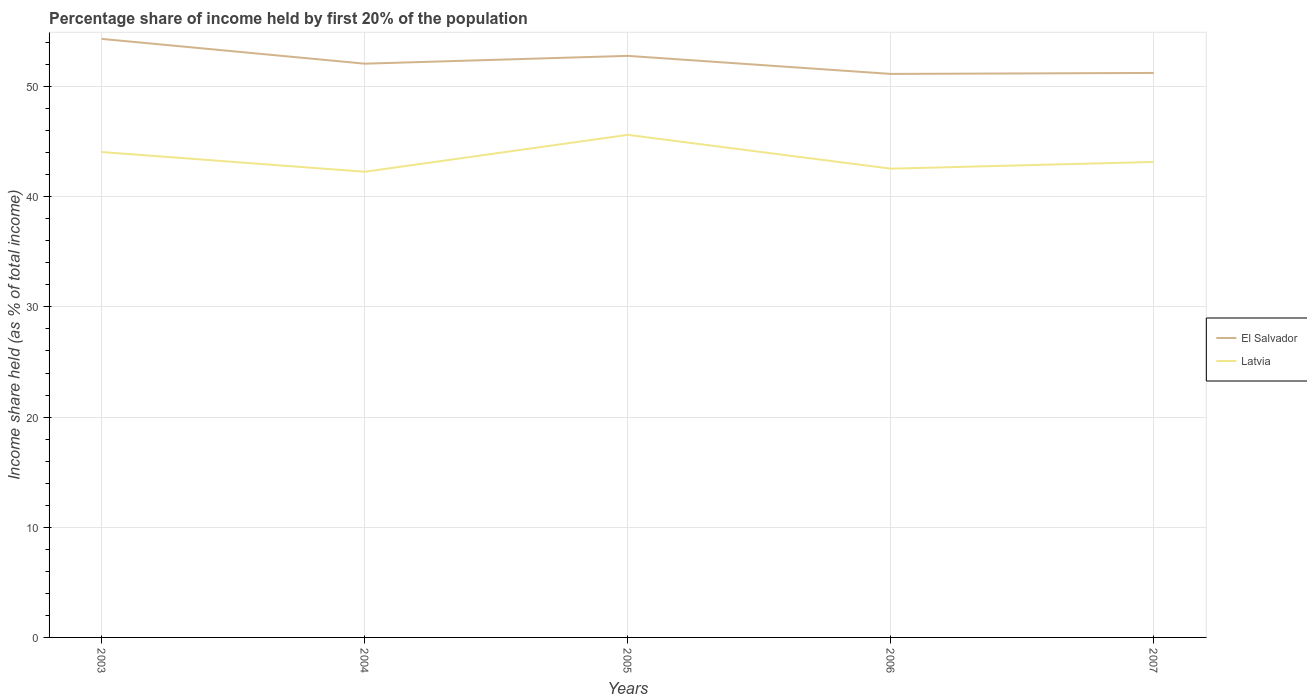How many different coloured lines are there?
Make the answer very short. 2. Does the line corresponding to Latvia intersect with the line corresponding to El Salvador?
Make the answer very short. No. Is the number of lines equal to the number of legend labels?
Provide a succinct answer. Yes. Across all years, what is the maximum share of income held by first 20% of the population in El Salvador?
Offer a very short reply. 51.15. What is the total share of income held by first 20% of the population in Latvia in the graph?
Your answer should be very brief. -0.28. What is the difference between the highest and the second highest share of income held by first 20% of the population in El Salvador?
Provide a short and direct response. 3.18. How many years are there in the graph?
Keep it short and to the point. 5. Does the graph contain any zero values?
Ensure brevity in your answer.  No. Does the graph contain grids?
Offer a very short reply. Yes. Where does the legend appear in the graph?
Keep it short and to the point. Center right. How are the legend labels stacked?
Offer a terse response. Vertical. What is the title of the graph?
Provide a short and direct response. Percentage share of income held by first 20% of the population. What is the label or title of the Y-axis?
Your response must be concise. Income share held (as % of total income). What is the Income share held (as % of total income) of El Salvador in 2003?
Make the answer very short. 54.33. What is the Income share held (as % of total income) of Latvia in 2003?
Give a very brief answer. 44.06. What is the Income share held (as % of total income) of El Salvador in 2004?
Your answer should be very brief. 52.08. What is the Income share held (as % of total income) of Latvia in 2004?
Provide a succinct answer. 42.27. What is the Income share held (as % of total income) of El Salvador in 2005?
Provide a succinct answer. 52.79. What is the Income share held (as % of total income) of Latvia in 2005?
Offer a terse response. 45.62. What is the Income share held (as % of total income) in El Salvador in 2006?
Offer a terse response. 51.15. What is the Income share held (as % of total income) of Latvia in 2006?
Provide a succinct answer. 42.55. What is the Income share held (as % of total income) of El Salvador in 2007?
Make the answer very short. 51.24. What is the Income share held (as % of total income) in Latvia in 2007?
Provide a short and direct response. 43.16. Across all years, what is the maximum Income share held (as % of total income) in El Salvador?
Provide a succinct answer. 54.33. Across all years, what is the maximum Income share held (as % of total income) of Latvia?
Your response must be concise. 45.62. Across all years, what is the minimum Income share held (as % of total income) of El Salvador?
Offer a terse response. 51.15. Across all years, what is the minimum Income share held (as % of total income) of Latvia?
Ensure brevity in your answer.  42.27. What is the total Income share held (as % of total income) of El Salvador in the graph?
Make the answer very short. 261.59. What is the total Income share held (as % of total income) in Latvia in the graph?
Your answer should be compact. 217.66. What is the difference between the Income share held (as % of total income) of El Salvador in 2003 and that in 2004?
Ensure brevity in your answer.  2.25. What is the difference between the Income share held (as % of total income) of Latvia in 2003 and that in 2004?
Give a very brief answer. 1.79. What is the difference between the Income share held (as % of total income) of El Salvador in 2003 and that in 2005?
Your response must be concise. 1.54. What is the difference between the Income share held (as % of total income) of Latvia in 2003 and that in 2005?
Provide a short and direct response. -1.56. What is the difference between the Income share held (as % of total income) in El Salvador in 2003 and that in 2006?
Your response must be concise. 3.18. What is the difference between the Income share held (as % of total income) of Latvia in 2003 and that in 2006?
Your answer should be compact. 1.51. What is the difference between the Income share held (as % of total income) of El Salvador in 2003 and that in 2007?
Ensure brevity in your answer.  3.09. What is the difference between the Income share held (as % of total income) in Latvia in 2003 and that in 2007?
Your answer should be very brief. 0.9. What is the difference between the Income share held (as % of total income) in El Salvador in 2004 and that in 2005?
Give a very brief answer. -0.71. What is the difference between the Income share held (as % of total income) of Latvia in 2004 and that in 2005?
Keep it short and to the point. -3.35. What is the difference between the Income share held (as % of total income) of El Salvador in 2004 and that in 2006?
Make the answer very short. 0.93. What is the difference between the Income share held (as % of total income) of Latvia in 2004 and that in 2006?
Offer a terse response. -0.28. What is the difference between the Income share held (as % of total income) in El Salvador in 2004 and that in 2007?
Your answer should be compact. 0.84. What is the difference between the Income share held (as % of total income) of Latvia in 2004 and that in 2007?
Your response must be concise. -0.89. What is the difference between the Income share held (as % of total income) of El Salvador in 2005 and that in 2006?
Offer a terse response. 1.64. What is the difference between the Income share held (as % of total income) of Latvia in 2005 and that in 2006?
Offer a very short reply. 3.07. What is the difference between the Income share held (as % of total income) in El Salvador in 2005 and that in 2007?
Offer a terse response. 1.55. What is the difference between the Income share held (as % of total income) of Latvia in 2005 and that in 2007?
Ensure brevity in your answer.  2.46. What is the difference between the Income share held (as % of total income) of El Salvador in 2006 and that in 2007?
Offer a very short reply. -0.09. What is the difference between the Income share held (as % of total income) in Latvia in 2006 and that in 2007?
Your answer should be compact. -0.61. What is the difference between the Income share held (as % of total income) in El Salvador in 2003 and the Income share held (as % of total income) in Latvia in 2004?
Make the answer very short. 12.06. What is the difference between the Income share held (as % of total income) of El Salvador in 2003 and the Income share held (as % of total income) of Latvia in 2005?
Your answer should be very brief. 8.71. What is the difference between the Income share held (as % of total income) in El Salvador in 2003 and the Income share held (as % of total income) in Latvia in 2006?
Your answer should be compact. 11.78. What is the difference between the Income share held (as % of total income) of El Salvador in 2003 and the Income share held (as % of total income) of Latvia in 2007?
Ensure brevity in your answer.  11.17. What is the difference between the Income share held (as % of total income) of El Salvador in 2004 and the Income share held (as % of total income) of Latvia in 2005?
Offer a very short reply. 6.46. What is the difference between the Income share held (as % of total income) of El Salvador in 2004 and the Income share held (as % of total income) of Latvia in 2006?
Give a very brief answer. 9.53. What is the difference between the Income share held (as % of total income) in El Salvador in 2004 and the Income share held (as % of total income) in Latvia in 2007?
Your response must be concise. 8.92. What is the difference between the Income share held (as % of total income) in El Salvador in 2005 and the Income share held (as % of total income) in Latvia in 2006?
Provide a short and direct response. 10.24. What is the difference between the Income share held (as % of total income) in El Salvador in 2005 and the Income share held (as % of total income) in Latvia in 2007?
Offer a terse response. 9.63. What is the difference between the Income share held (as % of total income) in El Salvador in 2006 and the Income share held (as % of total income) in Latvia in 2007?
Your answer should be compact. 7.99. What is the average Income share held (as % of total income) of El Salvador per year?
Offer a very short reply. 52.32. What is the average Income share held (as % of total income) of Latvia per year?
Give a very brief answer. 43.53. In the year 2003, what is the difference between the Income share held (as % of total income) of El Salvador and Income share held (as % of total income) of Latvia?
Make the answer very short. 10.27. In the year 2004, what is the difference between the Income share held (as % of total income) in El Salvador and Income share held (as % of total income) in Latvia?
Provide a succinct answer. 9.81. In the year 2005, what is the difference between the Income share held (as % of total income) of El Salvador and Income share held (as % of total income) of Latvia?
Make the answer very short. 7.17. In the year 2006, what is the difference between the Income share held (as % of total income) of El Salvador and Income share held (as % of total income) of Latvia?
Provide a succinct answer. 8.6. In the year 2007, what is the difference between the Income share held (as % of total income) of El Salvador and Income share held (as % of total income) of Latvia?
Ensure brevity in your answer.  8.08. What is the ratio of the Income share held (as % of total income) of El Salvador in 2003 to that in 2004?
Your response must be concise. 1.04. What is the ratio of the Income share held (as % of total income) in Latvia in 2003 to that in 2004?
Offer a terse response. 1.04. What is the ratio of the Income share held (as % of total income) in El Salvador in 2003 to that in 2005?
Your answer should be very brief. 1.03. What is the ratio of the Income share held (as % of total income) of Latvia in 2003 to that in 2005?
Offer a very short reply. 0.97. What is the ratio of the Income share held (as % of total income) in El Salvador in 2003 to that in 2006?
Your response must be concise. 1.06. What is the ratio of the Income share held (as % of total income) of Latvia in 2003 to that in 2006?
Provide a short and direct response. 1.04. What is the ratio of the Income share held (as % of total income) of El Salvador in 2003 to that in 2007?
Make the answer very short. 1.06. What is the ratio of the Income share held (as % of total income) in Latvia in 2003 to that in 2007?
Your answer should be very brief. 1.02. What is the ratio of the Income share held (as % of total income) in El Salvador in 2004 to that in 2005?
Your response must be concise. 0.99. What is the ratio of the Income share held (as % of total income) in Latvia in 2004 to that in 2005?
Provide a short and direct response. 0.93. What is the ratio of the Income share held (as % of total income) of El Salvador in 2004 to that in 2006?
Provide a short and direct response. 1.02. What is the ratio of the Income share held (as % of total income) in El Salvador in 2004 to that in 2007?
Provide a short and direct response. 1.02. What is the ratio of the Income share held (as % of total income) of Latvia in 2004 to that in 2007?
Your answer should be compact. 0.98. What is the ratio of the Income share held (as % of total income) in El Salvador in 2005 to that in 2006?
Offer a very short reply. 1.03. What is the ratio of the Income share held (as % of total income) of Latvia in 2005 to that in 2006?
Your response must be concise. 1.07. What is the ratio of the Income share held (as % of total income) of El Salvador in 2005 to that in 2007?
Your answer should be compact. 1.03. What is the ratio of the Income share held (as % of total income) in Latvia in 2005 to that in 2007?
Your answer should be very brief. 1.06. What is the ratio of the Income share held (as % of total income) of El Salvador in 2006 to that in 2007?
Provide a short and direct response. 1. What is the ratio of the Income share held (as % of total income) in Latvia in 2006 to that in 2007?
Keep it short and to the point. 0.99. What is the difference between the highest and the second highest Income share held (as % of total income) in El Salvador?
Your answer should be compact. 1.54. What is the difference between the highest and the second highest Income share held (as % of total income) of Latvia?
Keep it short and to the point. 1.56. What is the difference between the highest and the lowest Income share held (as % of total income) of El Salvador?
Ensure brevity in your answer.  3.18. What is the difference between the highest and the lowest Income share held (as % of total income) in Latvia?
Offer a terse response. 3.35. 